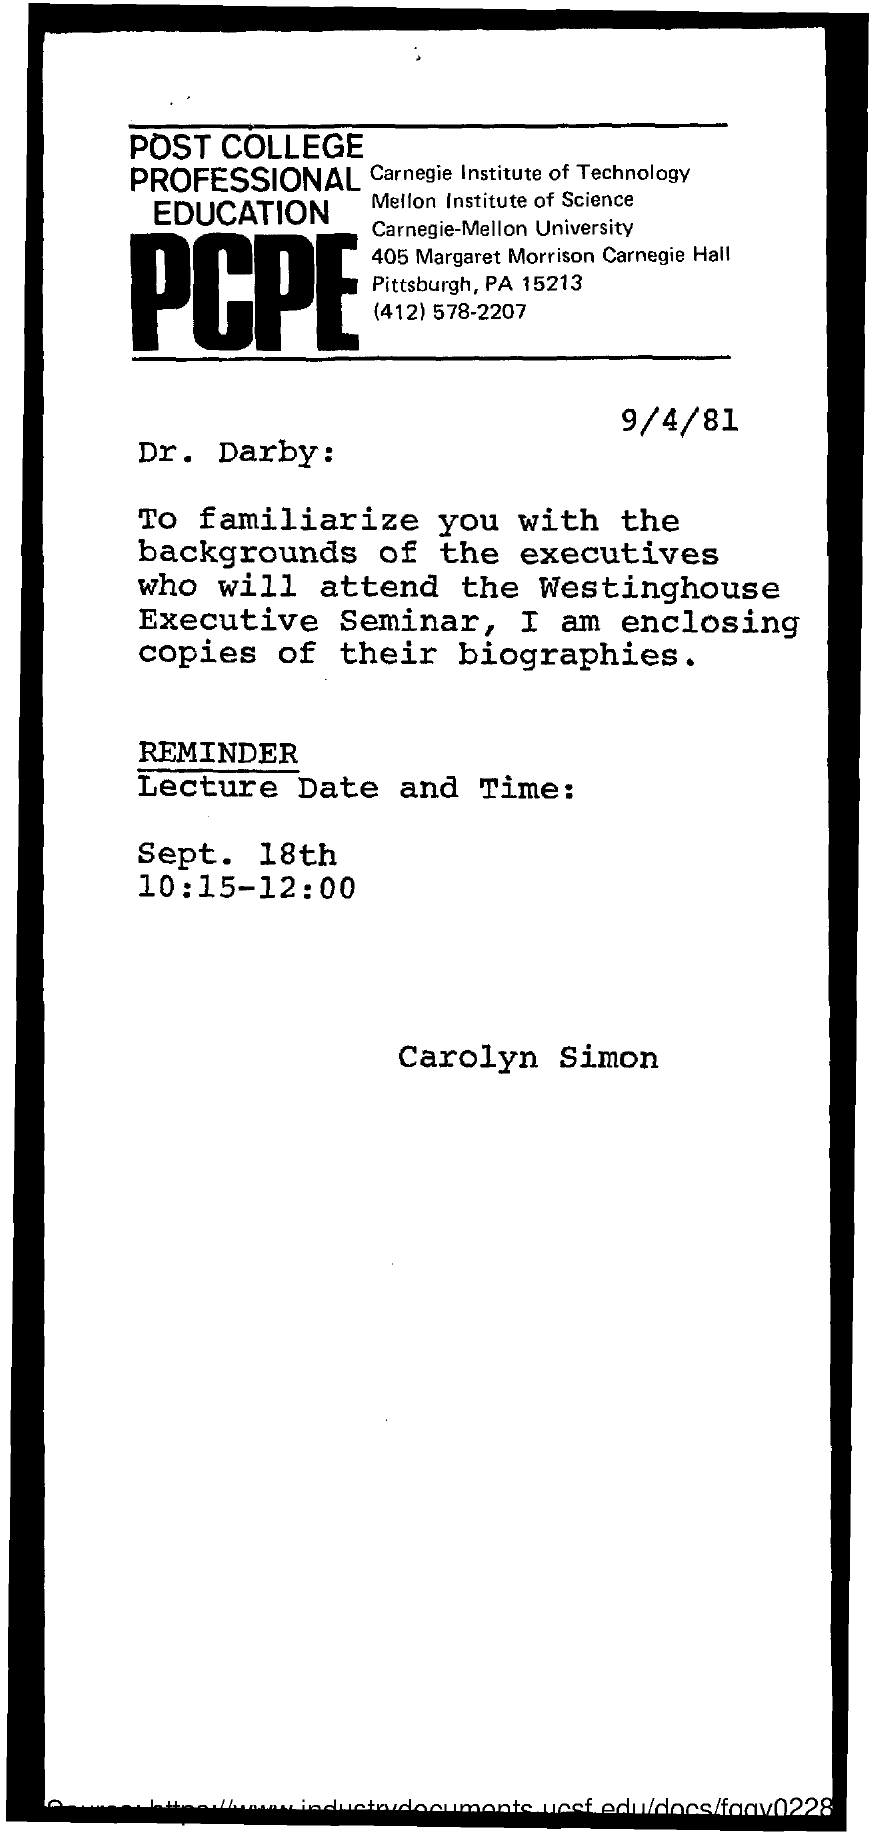On which date this letter was written ?
Ensure brevity in your answer.  9/4/81. 